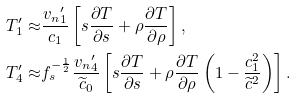Convert formula to latex. <formula><loc_0><loc_0><loc_500><loc_500>T ^ { \prime } _ { 1 } \approx & \frac { { v _ { n } } _ { 1 } ^ { \prime } } { c _ { 1 } } \left [ s \frac { \partial T } { \partial s } + \rho \frac { \partial T } { \partial \rho } \right ] , \\ T ^ { \prime } _ { 4 } \approx & f _ { s } ^ { - \frac { 1 } { 2 } } \frac { { v _ { n } } _ { 4 } ^ { \prime } } { \widetilde { c } _ { 0 } } \left [ s \frac { \partial T } { \partial s } + \rho \frac { \partial T } { \partial \rho } \left ( 1 - \frac { c _ { 1 } ^ { 2 } } { \widetilde { c } ^ { 2 } } \right ) \right ] .</formula> 